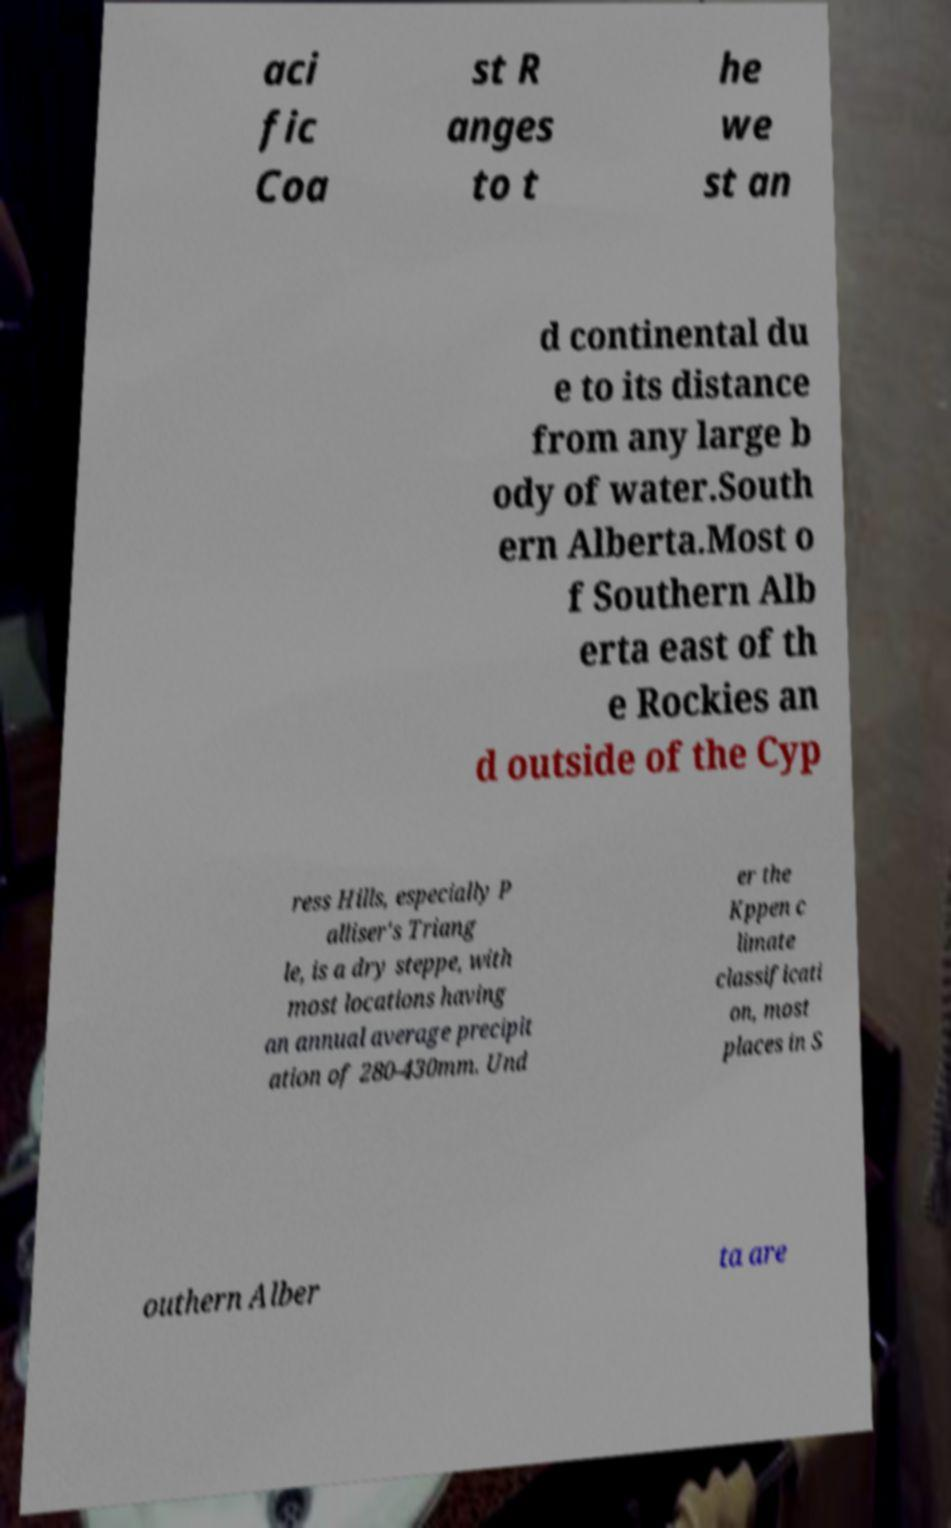Could you assist in decoding the text presented in this image and type it out clearly? aci fic Coa st R anges to t he we st an d continental du e to its distance from any large b ody of water.South ern Alberta.Most o f Southern Alb erta east of th e Rockies an d outside of the Cyp ress Hills, especially P alliser's Triang le, is a dry steppe, with most locations having an annual average precipit ation of 280-430mm. Und er the Kppen c limate classificati on, most places in S outhern Alber ta are 